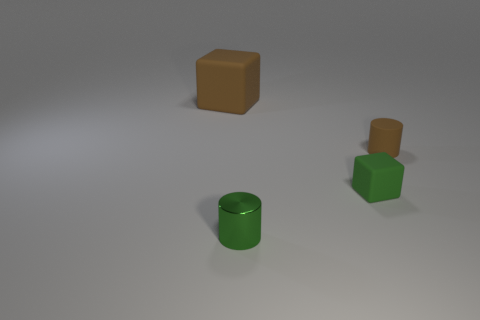Add 3 metallic things. How many objects exist? 7 Subtract all gray blocks. Subtract all green objects. How many objects are left? 2 Add 4 large things. How many large things are left? 5 Add 3 small green shiny spheres. How many small green shiny spheres exist? 3 Subtract 0 cyan blocks. How many objects are left? 4 